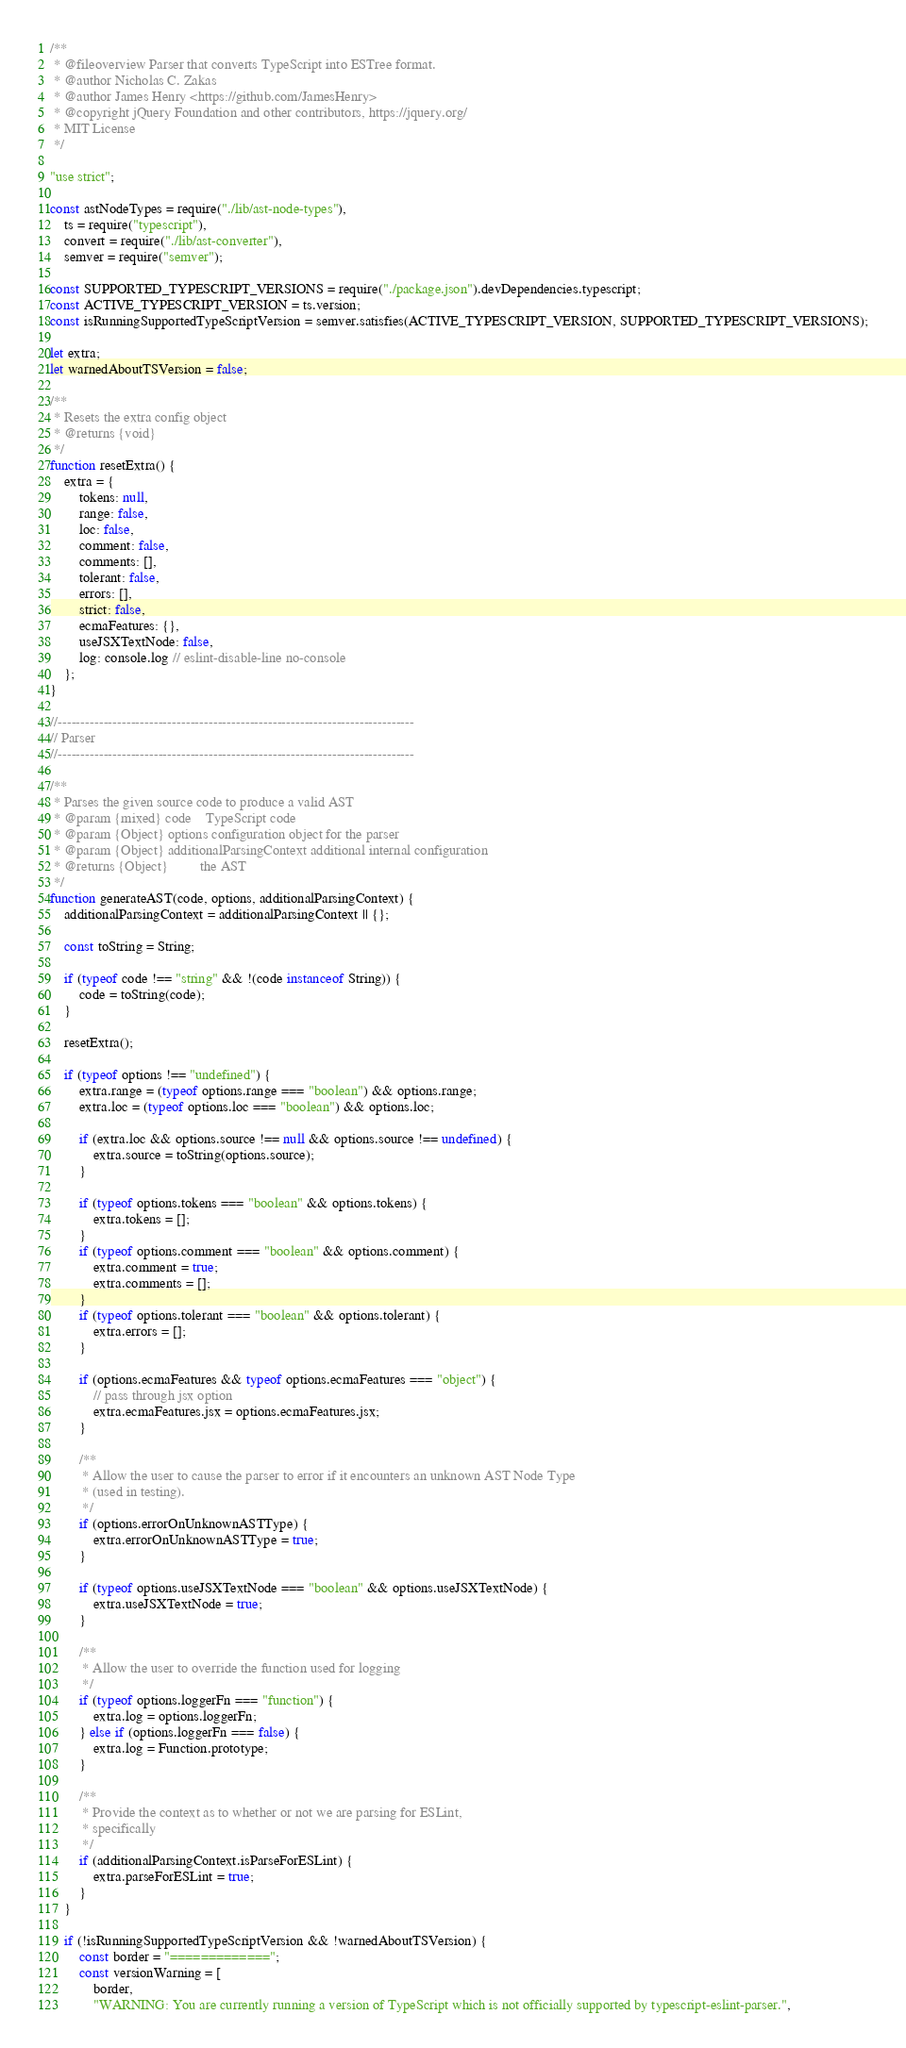Convert code to text. <code><loc_0><loc_0><loc_500><loc_500><_JavaScript_>/**
 * @fileoverview Parser that converts TypeScript into ESTree format.
 * @author Nicholas C. Zakas
 * @author James Henry <https://github.com/JamesHenry>
 * @copyright jQuery Foundation and other contributors, https://jquery.org/
 * MIT License
 */

"use strict";

const astNodeTypes = require("./lib/ast-node-types"),
    ts = require("typescript"),
    convert = require("./lib/ast-converter"),
    semver = require("semver");

const SUPPORTED_TYPESCRIPT_VERSIONS = require("./package.json").devDependencies.typescript;
const ACTIVE_TYPESCRIPT_VERSION = ts.version;
const isRunningSupportedTypeScriptVersion = semver.satisfies(ACTIVE_TYPESCRIPT_VERSION, SUPPORTED_TYPESCRIPT_VERSIONS);

let extra;
let warnedAboutTSVersion = false;

/**
 * Resets the extra config object
 * @returns {void}
 */
function resetExtra() {
    extra = {
        tokens: null,
        range: false,
        loc: false,
        comment: false,
        comments: [],
        tolerant: false,
        errors: [],
        strict: false,
        ecmaFeatures: {},
        useJSXTextNode: false,
        log: console.log // eslint-disable-line no-console
    };
}

//------------------------------------------------------------------------------
// Parser
//------------------------------------------------------------------------------

/**
 * Parses the given source code to produce a valid AST
 * @param {mixed} code    TypeScript code
 * @param {Object} options configuration object for the parser
 * @param {Object} additionalParsingContext additional internal configuration
 * @returns {Object}         the AST
 */
function generateAST(code, options, additionalParsingContext) {
    additionalParsingContext = additionalParsingContext || {};

    const toString = String;

    if (typeof code !== "string" && !(code instanceof String)) {
        code = toString(code);
    }

    resetExtra();

    if (typeof options !== "undefined") {
        extra.range = (typeof options.range === "boolean") && options.range;
        extra.loc = (typeof options.loc === "boolean") && options.loc;

        if (extra.loc && options.source !== null && options.source !== undefined) {
            extra.source = toString(options.source);
        }

        if (typeof options.tokens === "boolean" && options.tokens) {
            extra.tokens = [];
        }
        if (typeof options.comment === "boolean" && options.comment) {
            extra.comment = true;
            extra.comments = [];
        }
        if (typeof options.tolerant === "boolean" && options.tolerant) {
            extra.errors = [];
        }

        if (options.ecmaFeatures && typeof options.ecmaFeatures === "object") {
            // pass through jsx option
            extra.ecmaFeatures.jsx = options.ecmaFeatures.jsx;
        }

        /**
         * Allow the user to cause the parser to error if it encounters an unknown AST Node Type
         * (used in testing).
         */
        if (options.errorOnUnknownASTType) {
            extra.errorOnUnknownASTType = true;
        }

        if (typeof options.useJSXTextNode === "boolean" && options.useJSXTextNode) {
            extra.useJSXTextNode = true;
        }

        /**
         * Allow the user to override the function used for logging
         */
        if (typeof options.loggerFn === "function") {
            extra.log = options.loggerFn;
        } else if (options.loggerFn === false) {
            extra.log = Function.prototype;
        }

        /**
         * Provide the context as to whether or not we are parsing for ESLint,
         * specifically
         */
        if (additionalParsingContext.isParseForESLint) {
            extra.parseForESLint = true;
        }
    }

    if (!isRunningSupportedTypeScriptVersion && !warnedAboutTSVersion) {
        const border = "=============";
        const versionWarning = [
            border,
            "WARNING: You are currently running a version of TypeScript which is not officially supported by typescript-eslint-parser.",</code> 